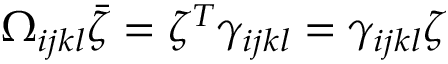Convert formula to latex. <formula><loc_0><loc_0><loc_500><loc_500>\Omega _ { i j k l } \bar { \zeta } = \zeta ^ { T } \gamma _ { i j k l } = \gamma _ { i j k l } \zeta</formula> 